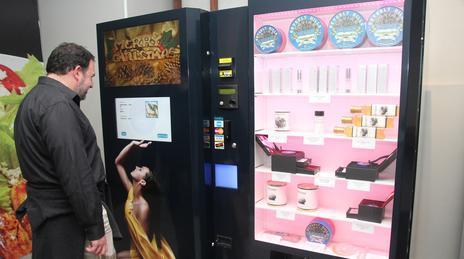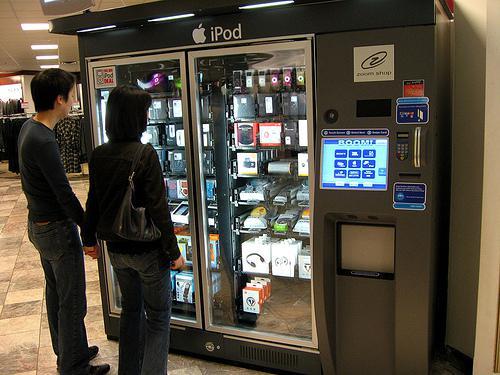The first image is the image on the left, the second image is the image on the right. Assess this claim about the two images: "The right image has at least one human facing towards the right in front of a vending machine.". Correct or not? Answer yes or no. Yes. The first image is the image on the left, the second image is the image on the right. For the images displayed, is the sentence "A person is standing directly in front of a vending machine decorated with a woman's image, in one picture." factually correct? Answer yes or no. Yes. 